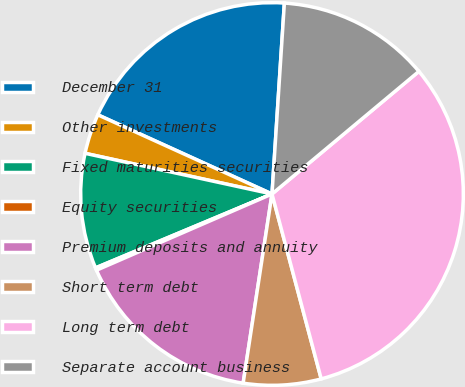<chart> <loc_0><loc_0><loc_500><loc_500><pie_chart><fcel>December 31<fcel>Other investments<fcel>Fixed maturities securities<fcel>Equity securities<fcel>Premium deposits and annuity<fcel>Short term debt<fcel>Long term debt<fcel>Separate account business<nl><fcel>19.24%<fcel>3.38%<fcel>9.72%<fcel>0.21%<fcel>16.07%<fcel>6.55%<fcel>31.93%<fcel>12.9%<nl></chart> 